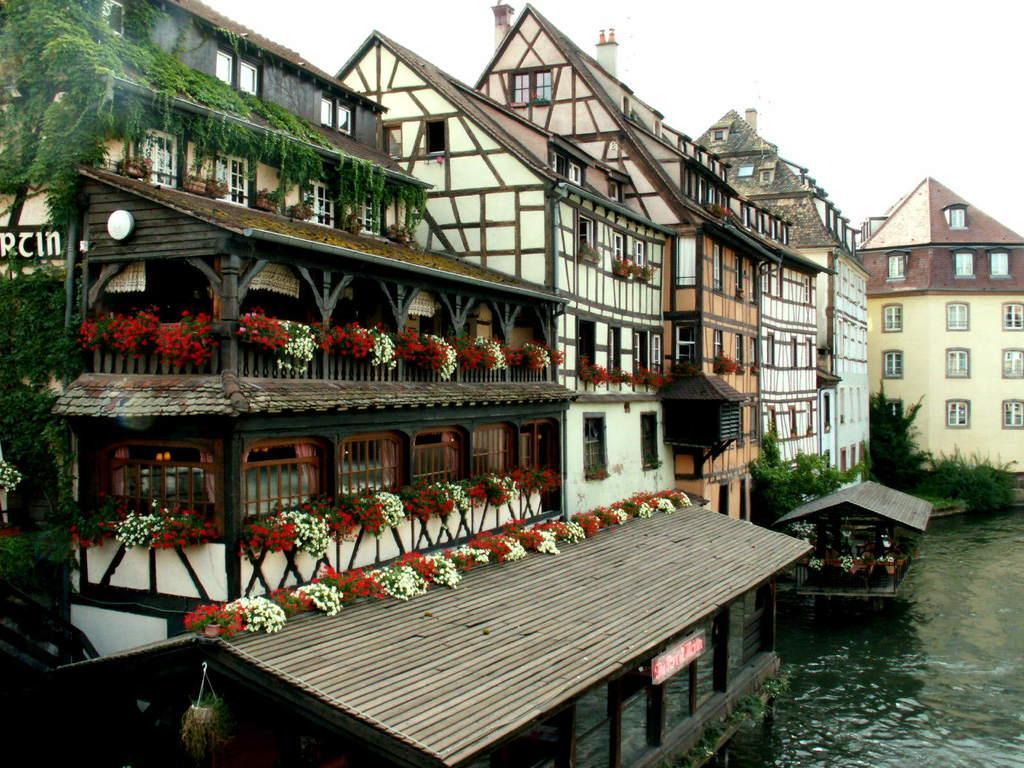Can you describe this image briefly? There are buildings and plants present in the middle of this image. We can see a water in the bottom right corner of this image and the sky is at the top of this image. 